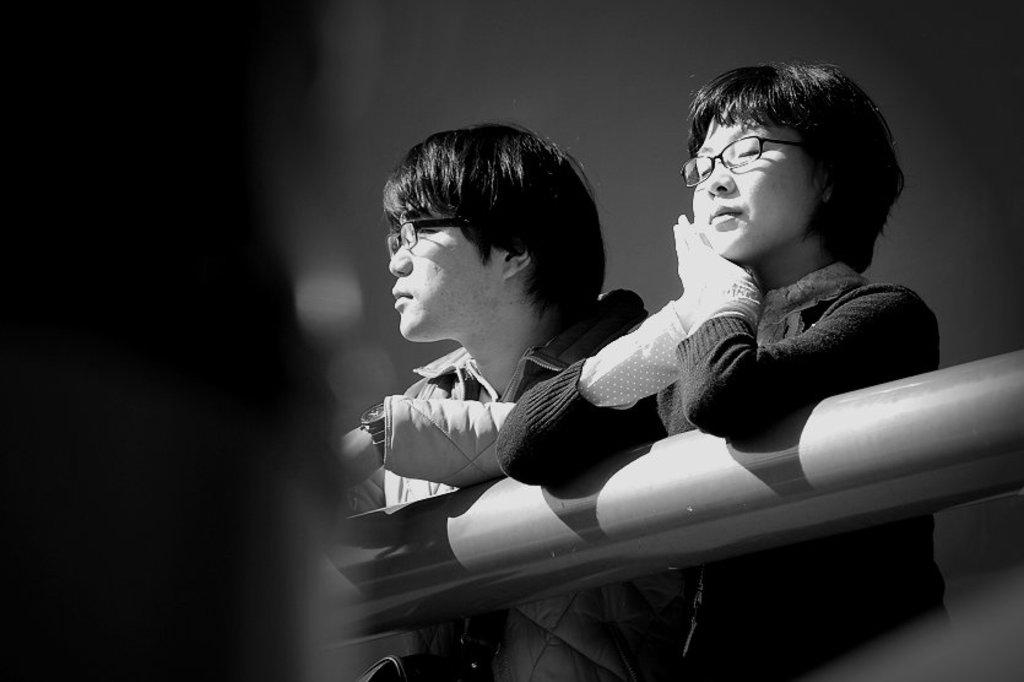What is the color scheme of the image? The image is black and white. Can you describe the people in the image? There is a man and a woman in the image, both wearing glasses. What object can be seen in the image besides the people? There is a pipe visible in the image. What type of animal is sitting on the chair in the image? There is no chair or animal present in the image. Can you describe the feather in the image? There is no feather present in the image. 